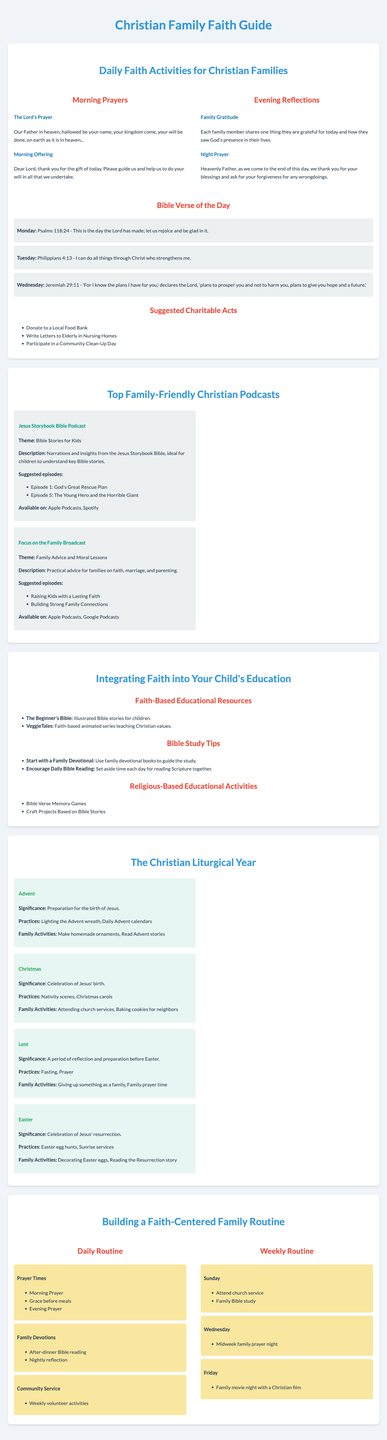What is the significance of Advent? The significance of Advent is preparation for the birth of Jesus.
Answer: Preparation for the birth of Jesus What is the Bible verse for Tuesday? The Bible verse for Tuesday is Philippians 4:13 - I can do all things through Christ who strengthens me.
Answer: Philippians 4:13 What are two suggested charitable acts? The document lists suggested charitable acts such as donating to a local food bank and writing letters to the elderly in nursing homes.
Answer: Donate to a Local Food Bank, Write Letters to Elderly in Nursing Homes How many activity categories are included in the Daily Faith Activities section? There are three main categories: Morning Prayers, Evening Reflections, and Suggested Charitable Acts.
Answer: Three Which podcast focuses on family advice and moral lessons? The podcast that focuses on family advice and moral lessons is "Focus on the Family Broadcast."
Answer: Focus on the Family Broadcast What day is suggested for midweek family prayer night? The suggested day for midweek family prayer night is Wednesday.
Answer: Wednesday What faith-based educational resource is listed for children? The Beginner's Bible is listed as a faith-based educational resource for children.
Answer: The Beginner's Bible What activities are suggested during the Christmas season? Suggested activities during the Christmas season include attending church services and baking cookies for neighbors.
Answer: Attending church services, Baking cookies for neighbors What is the theme of the "Jesus Storybook Bible Podcast"? The theme of the Jesus Storybook Bible Podcast is Bible Stories for Kids.
Answer: Bible Stories for Kids 